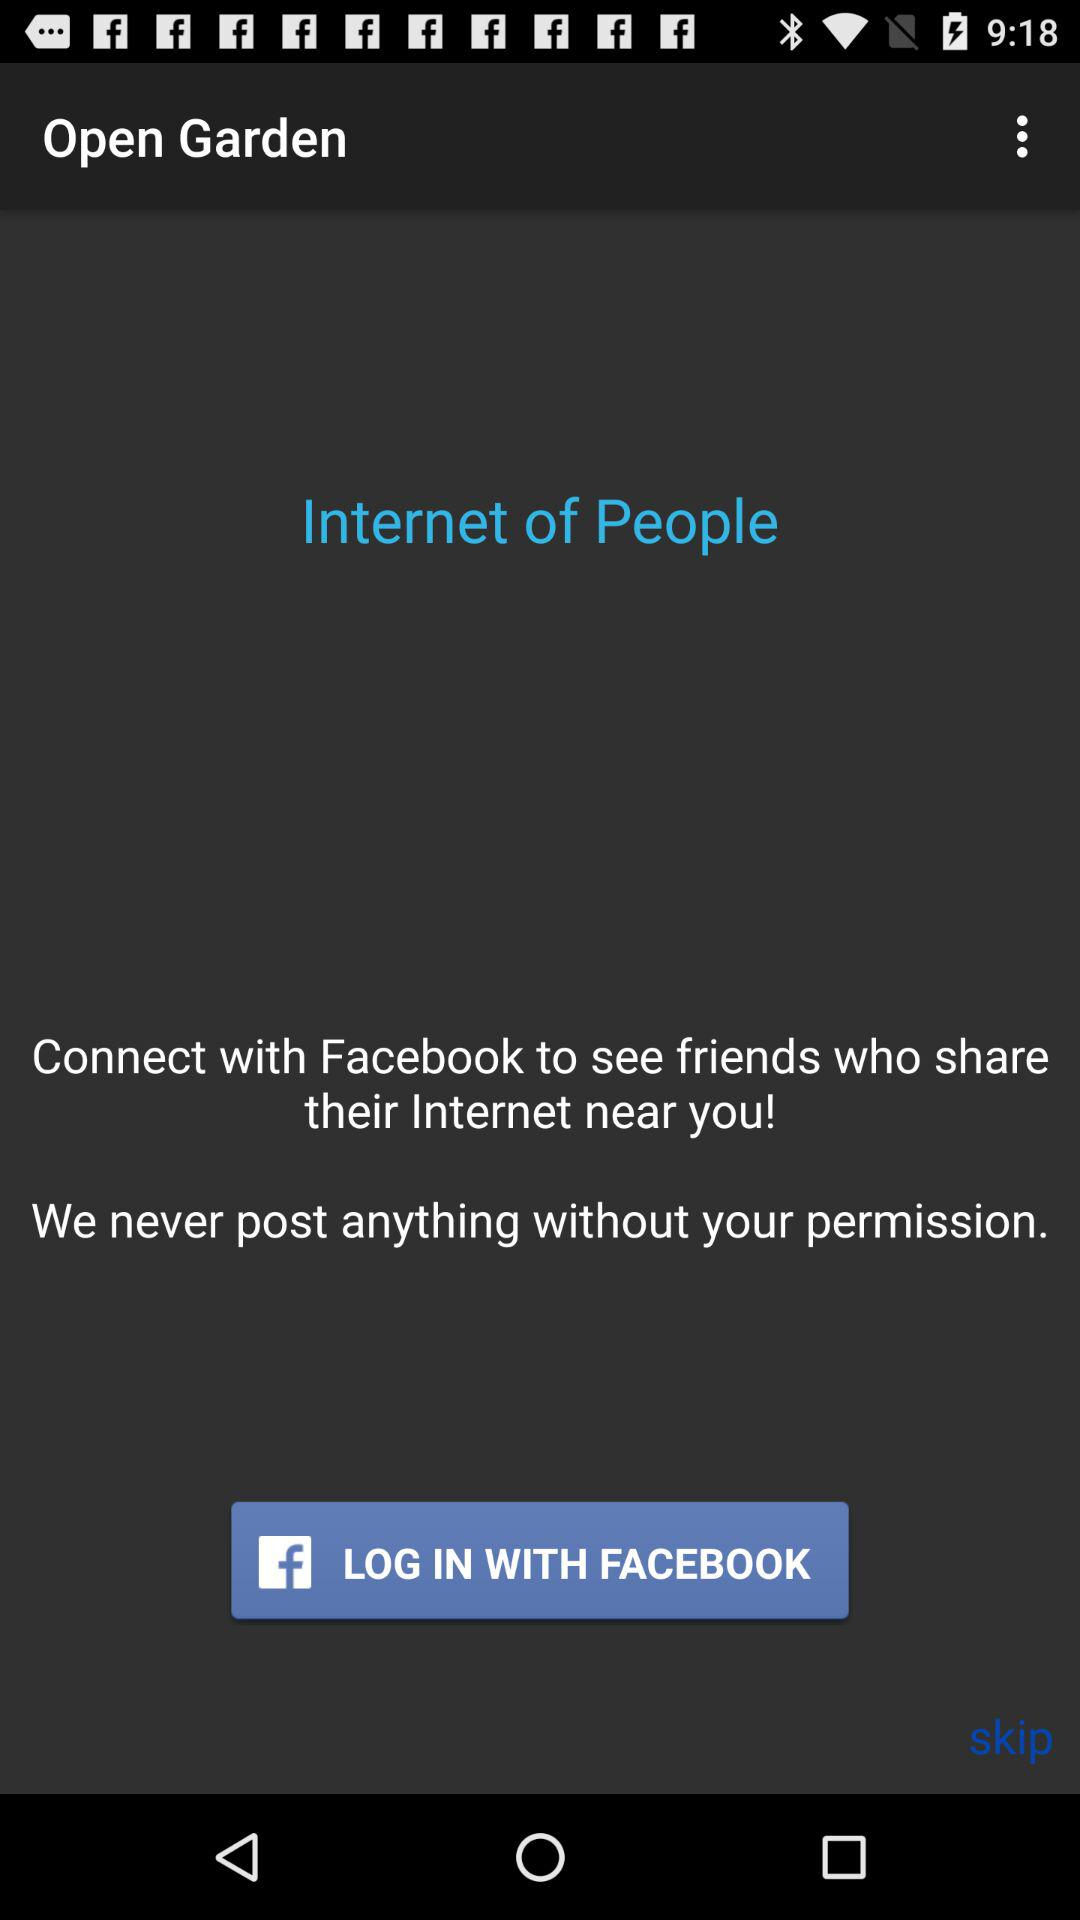With what application can we log in? You can log in with "FACEBOOK". 